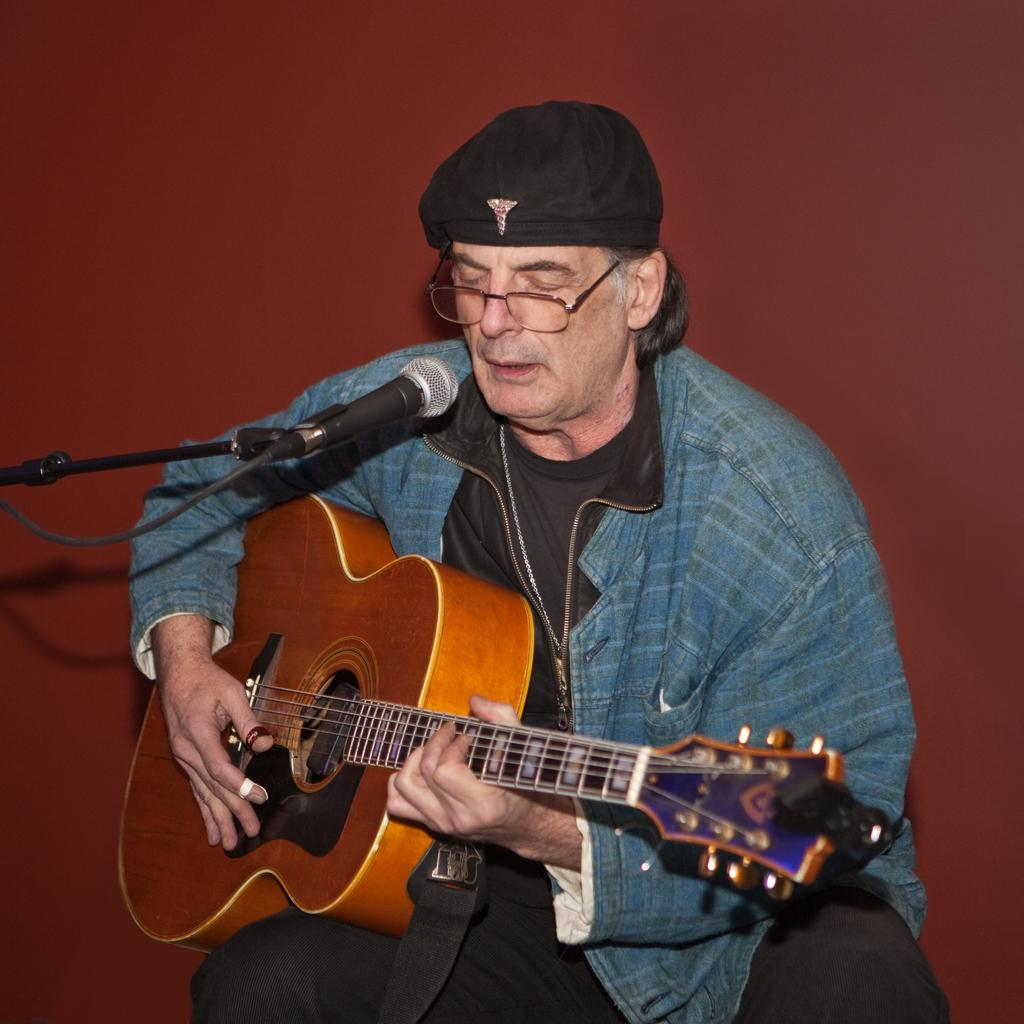What is the man in the image doing? The man is sitting and playing a guitar. What object is present in the image that is typically used for amplifying sound? There is a microphone with a stand in the image. What color is the wall visible in the background of the image? The wall in the background of the image is maroon-colored. What type of ornament is hanging from the ceiling in the image? There is no ornament hanging from the ceiling in the image. What kind of band is performing in the image? The image only shows a man playing a guitar, so it cannot be determined if there is a band performing. 